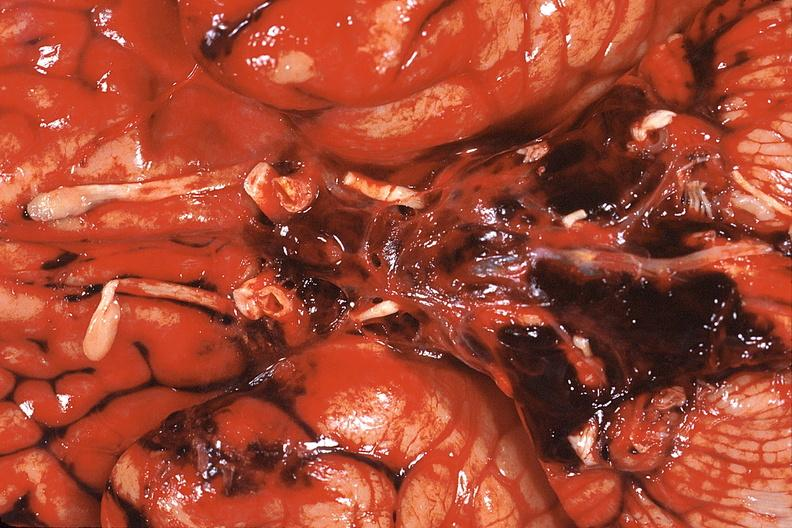does this image show brain, edema herniation right cingulate gyrus?
Answer the question using a single word or phrase. Yes 